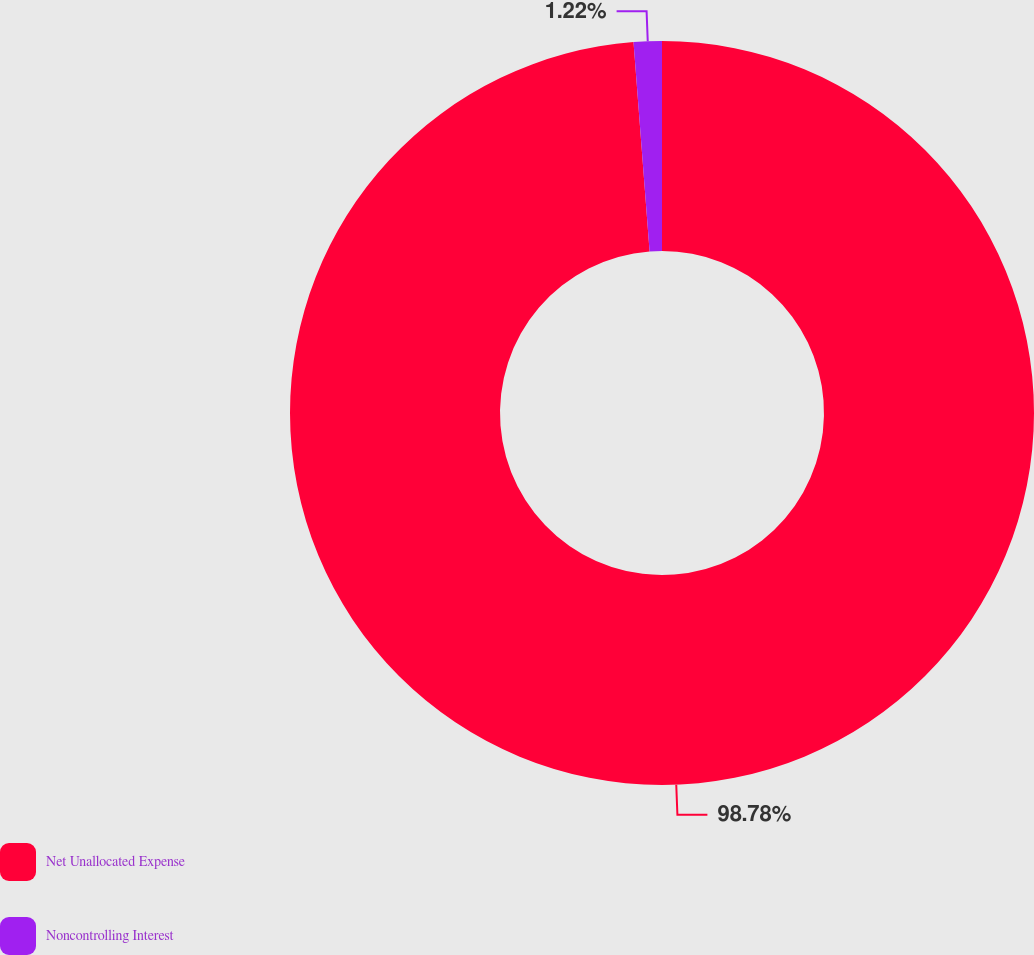Convert chart to OTSL. <chart><loc_0><loc_0><loc_500><loc_500><pie_chart><fcel>Net Unallocated Expense<fcel>Noncontrolling Interest<nl><fcel>98.78%<fcel>1.22%<nl></chart> 